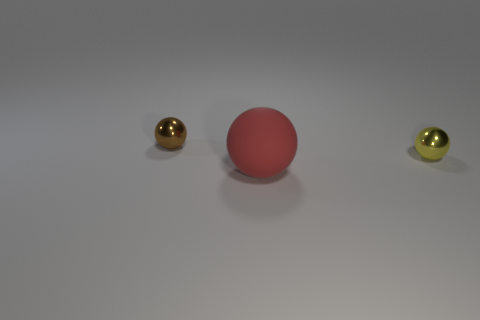Add 1 tiny yellow objects. How many objects exist? 4 Add 2 large blue rubber cubes. How many large blue rubber cubes exist? 2 Subtract 0 green spheres. How many objects are left? 3 Subtract all tiny blue matte blocks. Subtract all small brown balls. How many objects are left? 2 Add 2 tiny brown balls. How many tiny brown balls are left? 3 